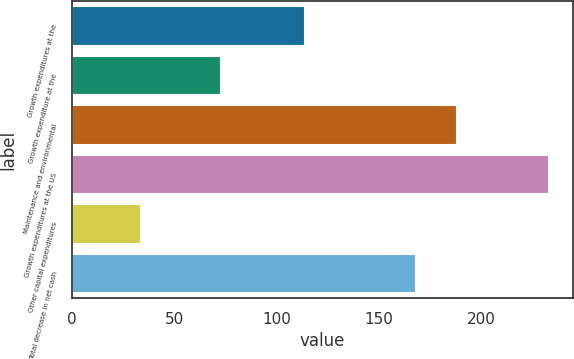Convert chart. <chart><loc_0><loc_0><loc_500><loc_500><bar_chart><fcel>Growth expenditures at the<fcel>Growth expenditure at the<fcel>Maintenance and environmental<fcel>Growth expenditures at the US<fcel>Other capital expenditures<fcel>Total decrease in net cash<nl><fcel>114<fcel>73<fcel>187.9<fcel>233<fcel>34<fcel>168<nl></chart> 